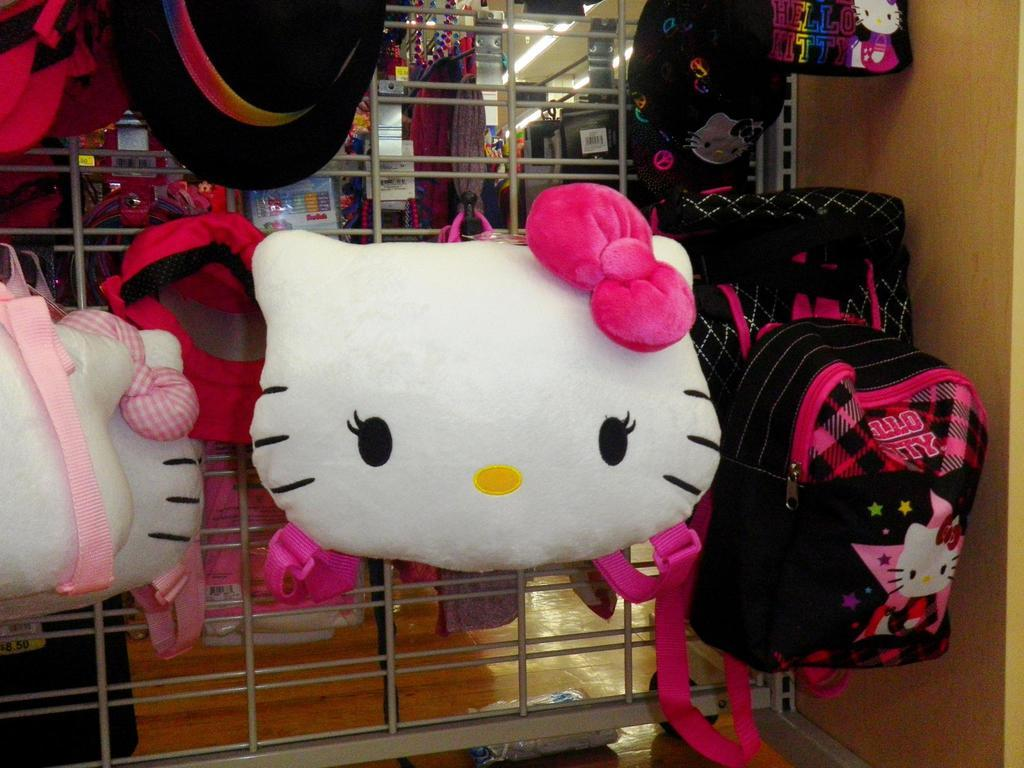What is hanging on the metal grill in the image? Caps and bags are hanging on a metal grill in the image. What type of establishment might the image be depicting? The image appears to be showing a store, as there are items visible. What can be seen on the ceiling in the image? There are lights on the ceiling in the image. Where is the sofa located in the image? There is no sofa present in the image. What type of game is being played on the floor in the image? There is no game or floor visible in the image. 